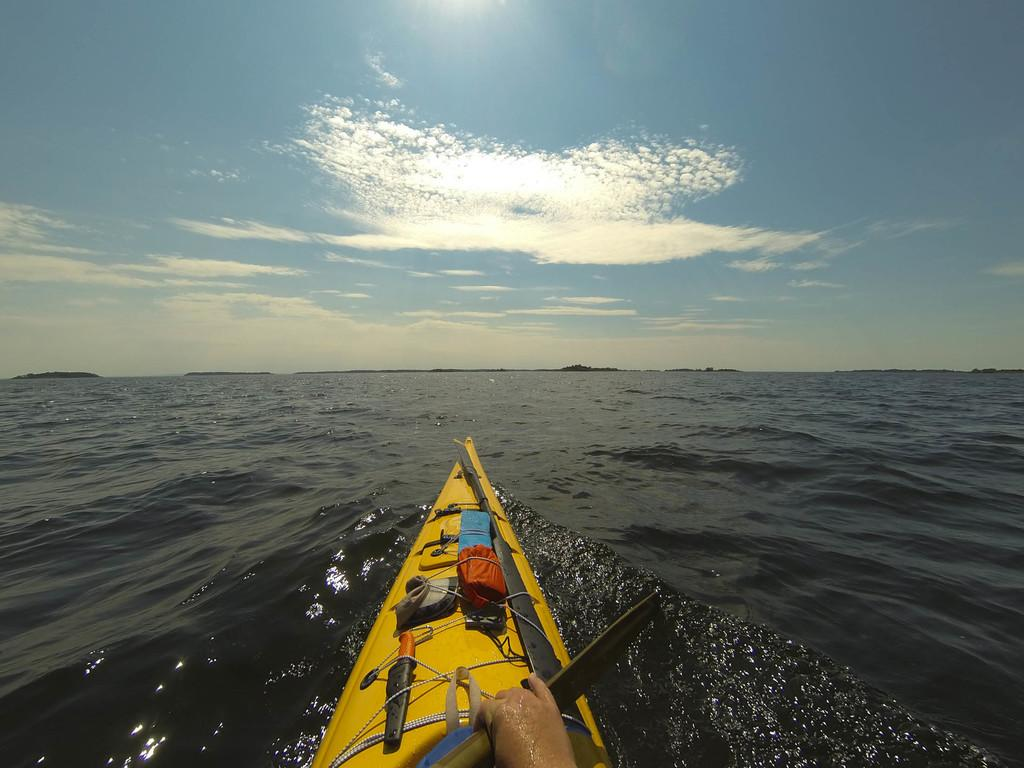What type of watercraft is in the image? There is a sea kayak in the image. What is the sea kayak doing in the image? The sea kayak is sailing on the water surface. Can you describe any human presence in the image? A person's hand is visible in the image. What type of lock is visible on the window in the image? There is no window or lock present in the image; it features a sea kayak sailing on the water surface. What color is the ink used to write on the paper in the image? There is no paper or ink present in the image. 